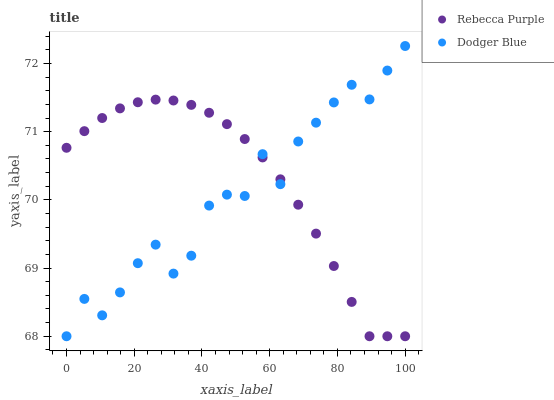Does Dodger Blue have the minimum area under the curve?
Answer yes or no. Yes. Does Rebecca Purple have the maximum area under the curve?
Answer yes or no. Yes. Does Rebecca Purple have the minimum area under the curve?
Answer yes or no. No. Is Rebecca Purple the smoothest?
Answer yes or no. Yes. Is Dodger Blue the roughest?
Answer yes or no. Yes. Is Rebecca Purple the roughest?
Answer yes or no. No. Does Dodger Blue have the lowest value?
Answer yes or no. Yes. Does Dodger Blue have the highest value?
Answer yes or no. Yes. Does Rebecca Purple have the highest value?
Answer yes or no. No. Does Dodger Blue intersect Rebecca Purple?
Answer yes or no. Yes. Is Dodger Blue less than Rebecca Purple?
Answer yes or no. No. Is Dodger Blue greater than Rebecca Purple?
Answer yes or no. No. 